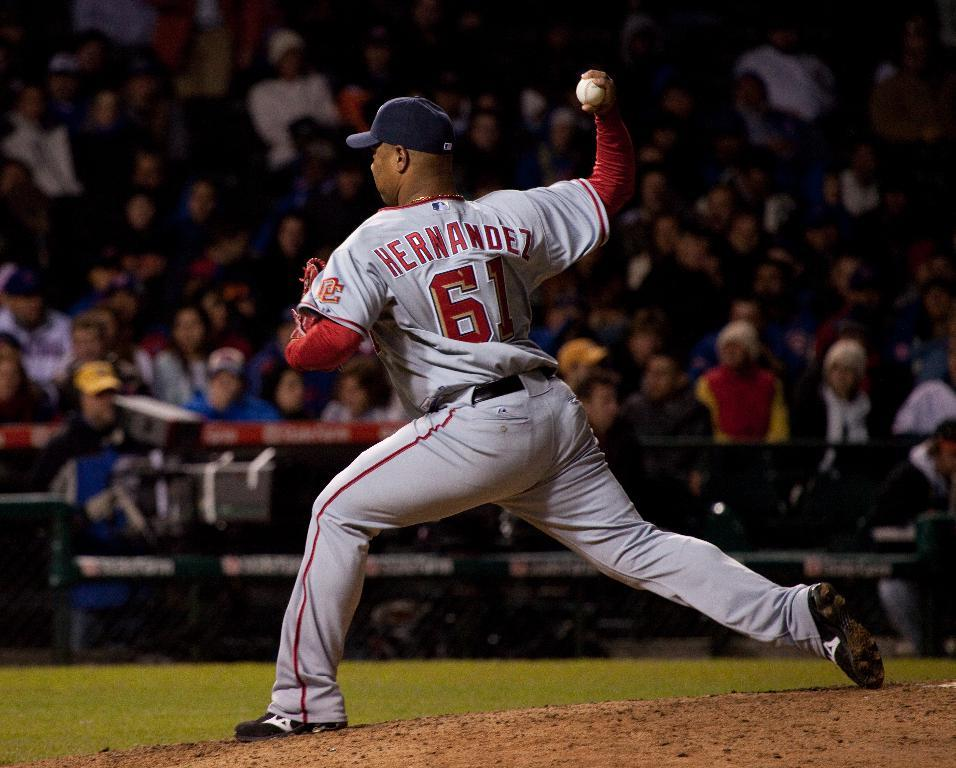<image>
Present a compact description of the photo's key features. The baseball player, Hernandez, is about to throw the ball. 